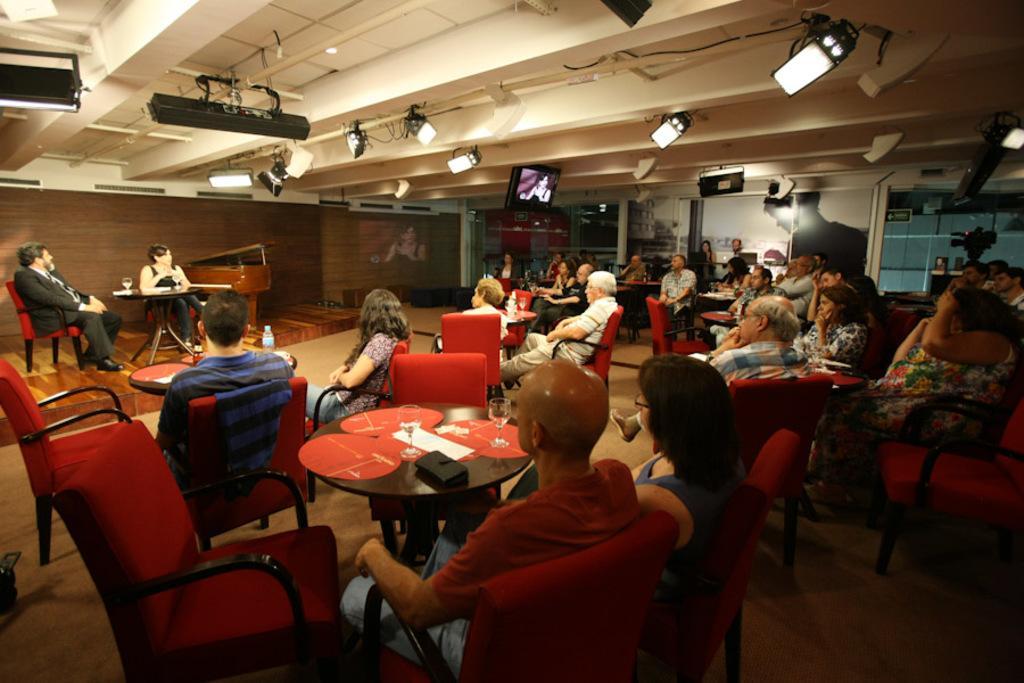How would you summarize this image in a sentence or two? This Picture shows a group of people seated on the chairs and we see few glasses on the table and we see a woman speaking with the help of a microphone and a man seated on the side on a chair 